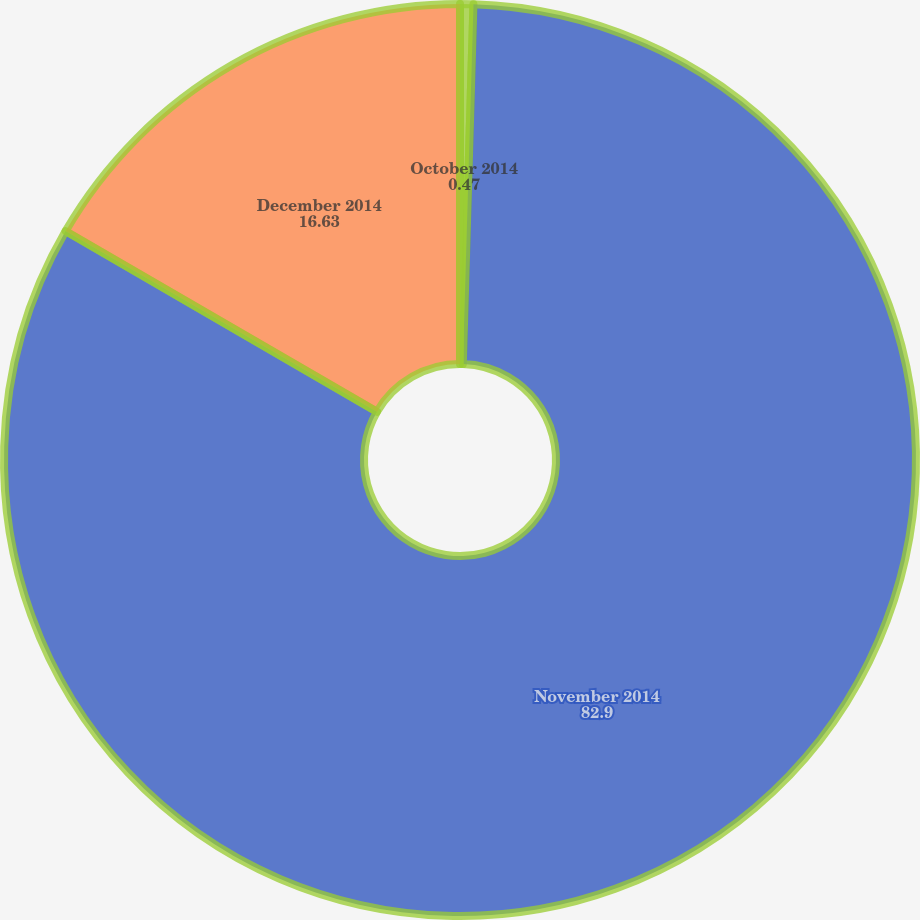<chart> <loc_0><loc_0><loc_500><loc_500><pie_chart><fcel>October 2014<fcel>November 2014<fcel>December 2014<nl><fcel>0.47%<fcel>82.9%<fcel>16.63%<nl></chart> 